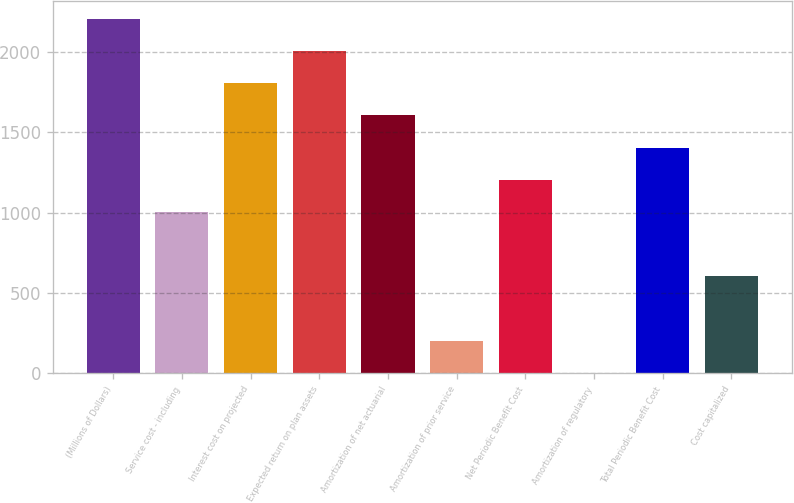Convert chart. <chart><loc_0><loc_0><loc_500><loc_500><bar_chart><fcel>(Millions of Dollars)<fcel>Service cost - including<fcel>Interest cost on projected<fcel>Expected return on plan assets<fcel>Amortization of net actuarial<fcel>Amortization of prior service<fcel>Net Periodic Benefit Cost<fcel>Amortization of regulatory<fcel>Total Periodic Benefit Cost<fcel>Cost capitalized<nl><fcel>2207.3<fcel>1005.5<fcel>1806.7<fcel>2007<fcel>1606.4<fcel>204.3<fcel>1205.8<fcel>4<fcel>1406.1<fcel>604.9<nl></chart> 